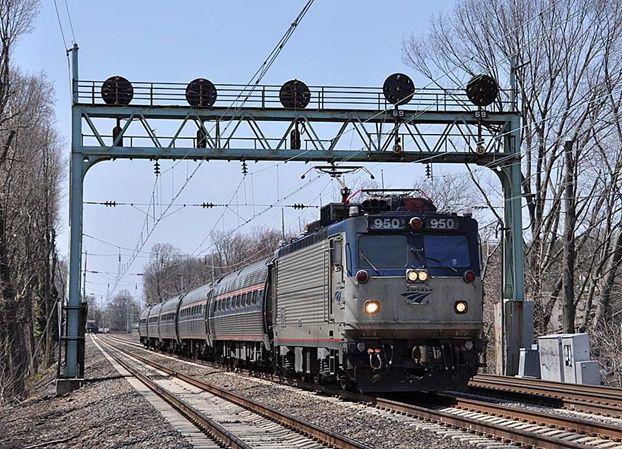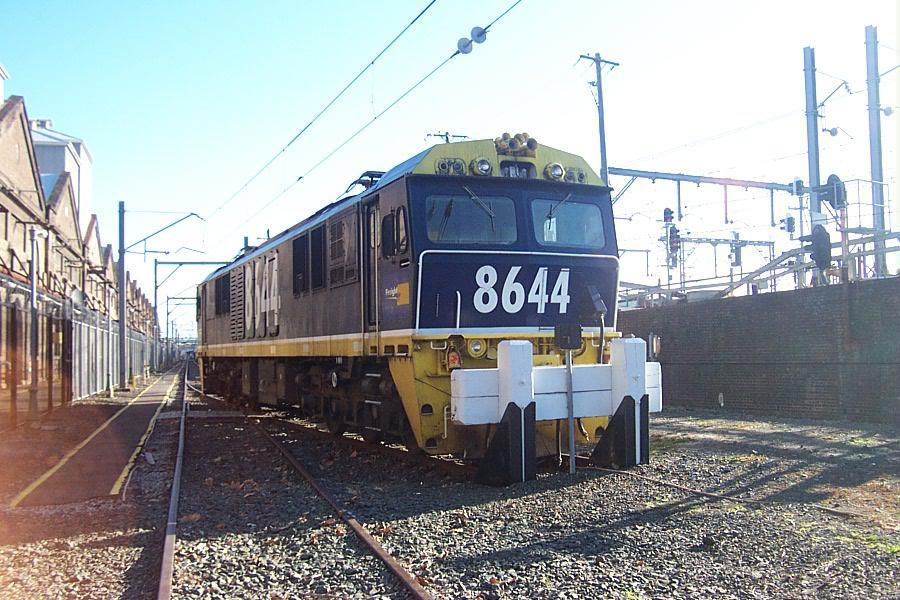The first image is the image on the left, the second image is the image on the right. Given the left and right images, does the statement "There are two trains in the pair of images, both traveling slightly towards the right." hold true? Answer yes or no. Yes. The first image is the image on the left, the second image is the image on the right. For the images shown, is this caption "Each image shows one train, which is heading rightward." true? Answer yes or no. Yes. 